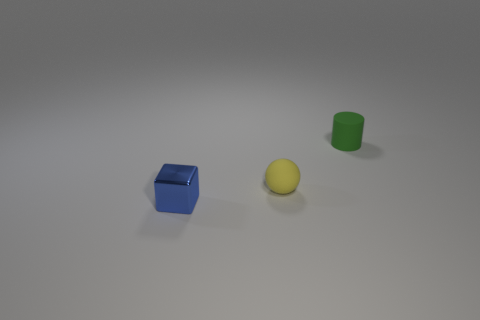Are there any other things that have the same shape as the small green rubber object?
Give a very brief answer. No. Are there any green rubber cylinders that are left of the rubber object that is in front of the thing that is on the right side of the tiny yellow object?
Keep it short and to the point. No. There is a metallic object that is the same size as the yellow matte ball; what is its color?
Your answer should be very brief. Blue. There is a thing that is in front of the small rubber cylinder and on the right side of the blue cube; what shape is it?
Your answer should be compact. Sphere. What size is the thing in front of the tiny rubber thing that is in front of the green matte cylinder?
Provide a short and direct response. Small. What number of other things are the same size as the blue object?
Provide a succinct answer. 2. What size is the thing that is behind the metallic thing and on the left side of the tiny matte cylinder?
Offer a terse response. Small. How many small yellow objects have the same shape as the small green rubber object?
Offer a very short reply. 0. What is the tiny cylinder made of?
Provide a short and direct response. Rubber. Is there a tiny thing that has the same material as the tiny yellow ball?
Ensure brevity in your answer.  Yes. 